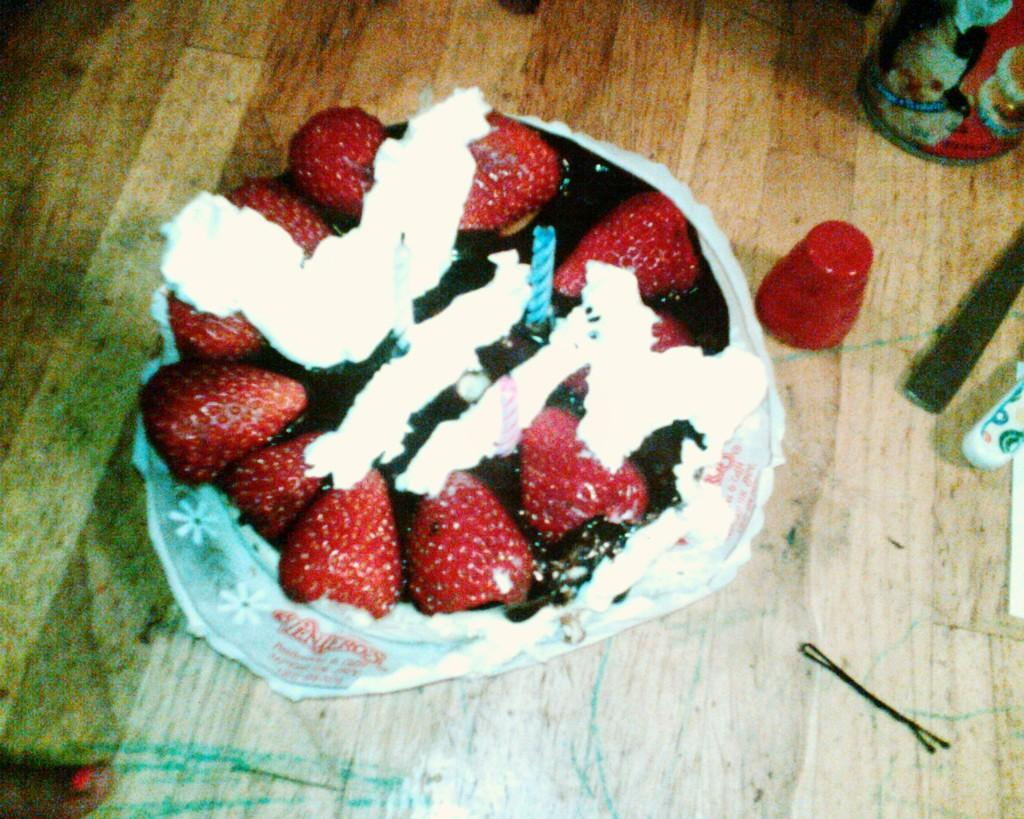What type of cake is on the table in the image? There is a strawberry cake on a table in the image. What objects are beside the cake on the table? There is a pen, a knife, and a bottle beside the cake on the table. Can you see any umbrellas open above the cake in the image? There are no umbrellas present in the image. Are there any horses visible in the image? There are no horses present in the image. 